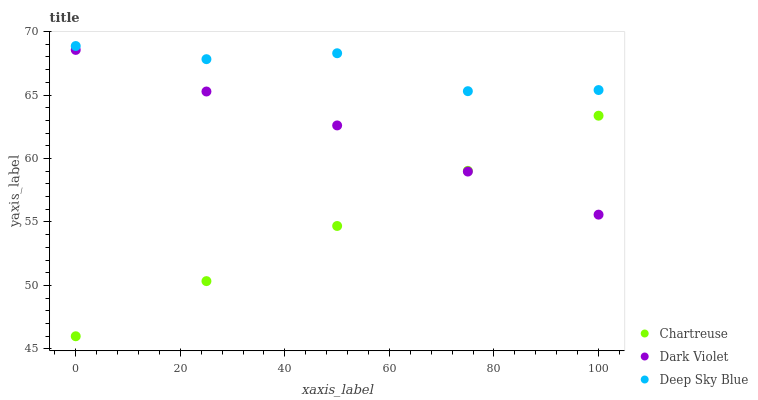Does Chartreuse have the minimum area under the curve?
Answer yes or no. Yes. Does Deep Sky Blue have the maximum area under the curve?
Answer yes or no. Yes. Does Dark Violet have the minimum area under the curve?
Answer yes or no. No. Does Dark Violet have the maximum area under the curve?
Answer yes or no. No. Is Chartreuse the smoothest?
Answer yes or no. Yes. Is Deep Sky Blue the roughest?
Answer yes or no. Yes. Is Dark Violet the smoothest?
Answer yes or no. No. Is Dark Violet the roughest?
Answer yes or no. No. Does Chartreuse have the lowest value?
Answer yes or no. Yes. Does Dark Violet have the lowest value?
Answer yes or no. No. Does Deep Sky Blue have the highest value?
Answer yes or no. Yes. Does Dark Violet have the highest value?
Answer yes or no. No. Is Dark Violet less than Deep Sky Blue?
Answer yes or no. Yes. Is Deep Sky Blue greater than Chartreuse?
Answer yes or no. Yes. Does Dark Violet intersect Chartreuse?
Answer yes or no. Yes. Is Dark Violet less than Chartreuse?
Answer yes or no. No. Is Dark Violet greater than Chartreuse?
Answer yes or no. No. Does Dark Violet intersect Deep Sky Blue?
Answer yes or no. No. 